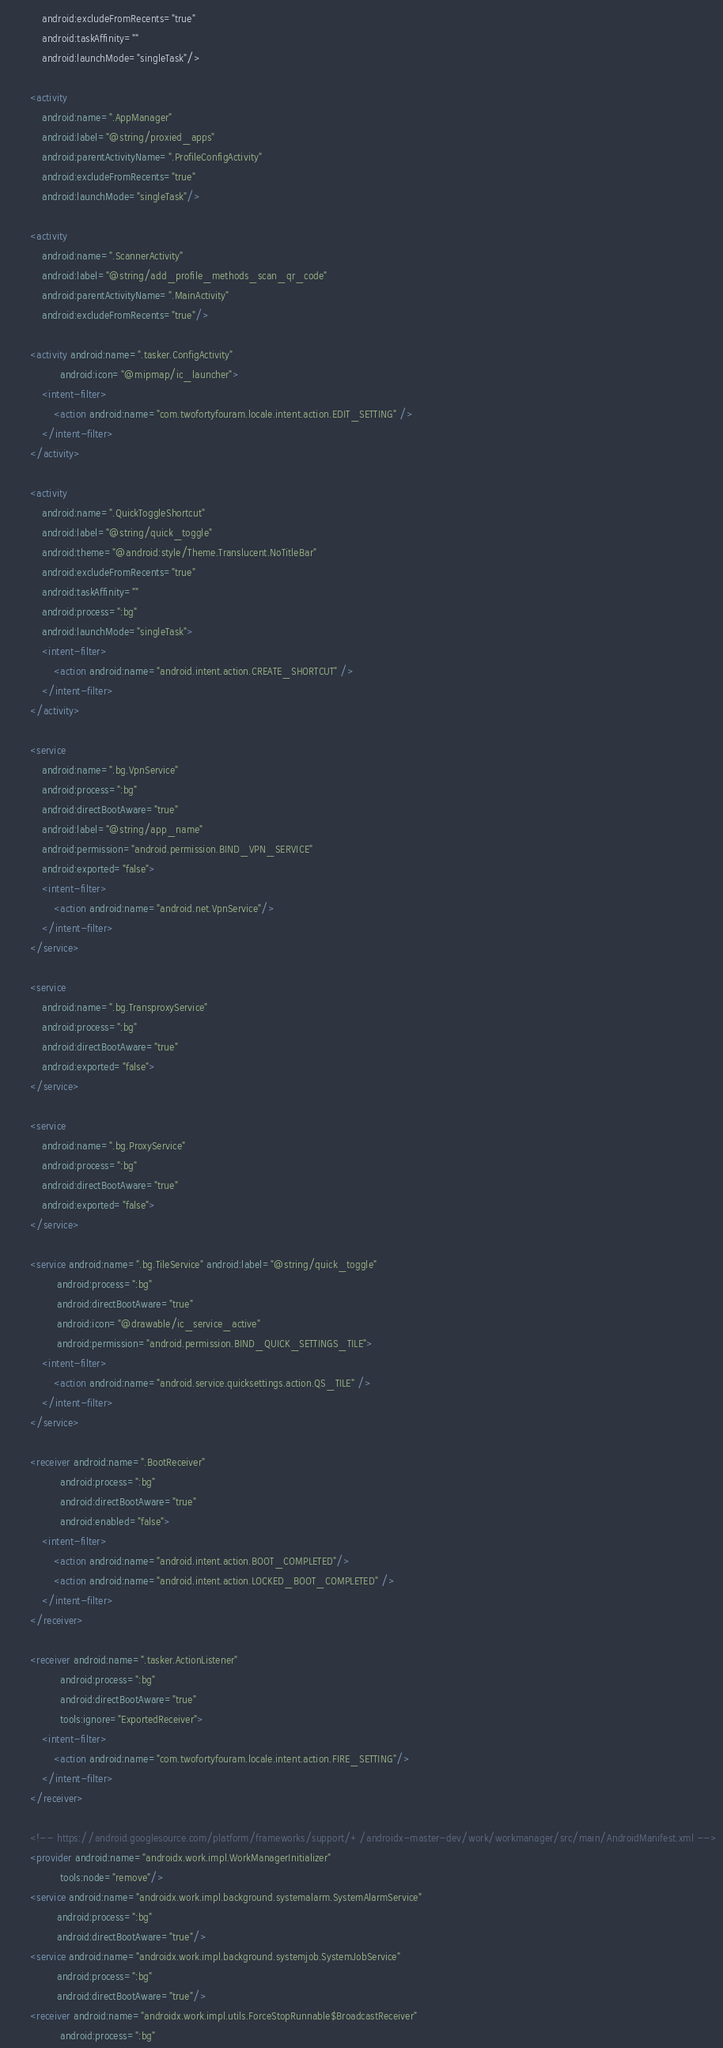<code> <loc_0><loc_0><loc_500><loc_500><_XML_>            android:excludeFromRecents="true"
            android:taskAffinity=""
            android:launchMode="singleTask"/>

        <activity
            android:name=".AppManager"
            android:label="@string/proxied_apps"
            android:parentActivityName=".ProfileConfigActivity"
            android:excludeFromRecents="true"
            android:launchMode="singleTask"/>

        <activity
            android:name=".ScannerActivity"
            android:label="@string/add_profile_methods_scan_qr_code"
            android:parentActivityName=".MainActivity"
            android:excludeFromRecents="true"/>

        <activity android:name=".tasker.ConfigActivity"
                  android:icon="@mipmap/ic_launcher">
            <intent-filter>
                <action android:name="com.twofortyfouram.locale.intent.action.EDIT_SETTING" />
            </intent-filter>
        </activity>

        <activity
            android:name=".QuickToggleShortcut"
            android:label="@string/quick_toggle"
            android:theme="@android:style/Theme.Translucent.NoTitleBar"
            android:excludeFromRecents="true"
            android:taskAffinity=""
            android:process=":bg"
            android:launchMode="singleTask">
            <intent-filter>
                <action android:name="android.intent.action.CREATE_SHORTCUT" />
            </intent-filter>
        </activity>

        <service
            android:name=".bg.VpnService"
            android:process=":bg"
            android:directBootAware="true"
            android:label="@string/app_name"
            android:permission="android.permission.BIND_VPN_SERVICE"
            android:exported="false">
            <intent-filter>
                <action android:name="android.net.VpnService"/>
            </intent-filter>
        </service>

        <service
            android:name=".bg.TransproxyService"
            android:process=":bg"
            android:directBootAware="true"
            android:exported="false">
        </service>

        <service
            android:name=".bg.ProxyService"
            android:process=":bg"
            android:directBootAware="true"
            android:exported="false">
        </service>

        <service android:name=".bg.TileService" android:label="@string/quick_toggle"
                 android:process=":bg"
                 android:directBootAware="true"
                 android:icon="@drawable/ic_service_active"
                 android:permission="android.permission.BIND_QUICK_SETTINGS_TILE">
            <intent-filter>
                <action android:name="android.service.quicksettings.action.QS_TILE" />
            </intent-filter>
        </service>

        <receiver android:name=".BootReceiver"
                  android:process=":bg"
                  android:directBootAware="true"
                  android:enabled="false">
            <intent-filter>
                <action android:name="android.intent.action.BOOT_COMPLETED"/>
                <action android:name="android.intent.action.LOCKED_BOOT_COMPLETED" />
            </intent-filter>
        </receiver>

        <receiver android:name=".tasker.ActionListener"
                  android:process=":bg"
                  android:directBootAware="true"
                  tools:ignore="ExportedReceiver">
            <intent-filter>
                <action android:name="com.twofortyfouram.locale.intent.action.FIRE_SETTING"/>
            </intent-filter>
        </receiver>

        <!-- https://android.googlesource.com/platform/frameworks/support/+/androidx-master-dev/work/workmanager/src/main/AndroidManifest.xml -->
        <provider android:name="androidx.work.impl.WorkManagerInitializer"
                  tools:node="remove"/>
        <service android:name="androidx.work.impl.background.systemalarm.SystemAlarmService"
                 android:process=":bg"
                 android:directBootAware="true"/>
        <service android:name="androidx.work.impl.background.systemjob.SystemJobService"
                 android:process=":bg"
                 android:directBootAware="true"/>
        <receiver android:name="androidx.work.impl.utils.ForceStopRunnable$BroadcastReceiver"
                  android:process=":bg"</code> 